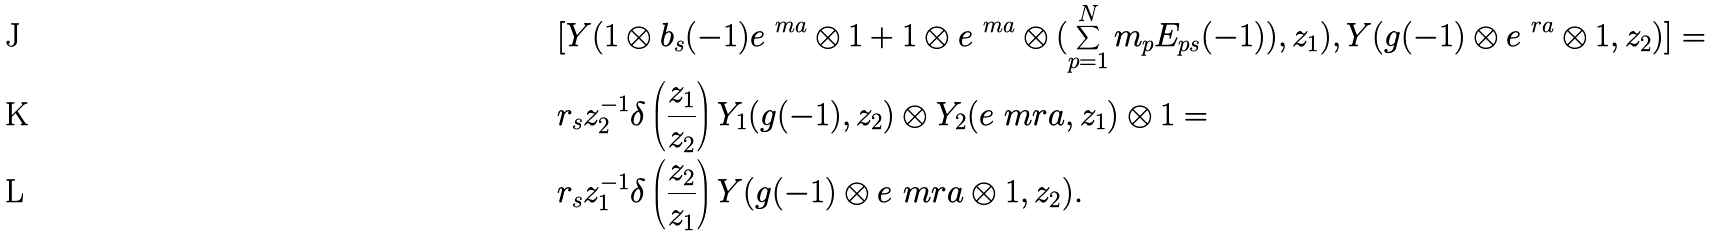<formula> <loc_0><loc_0><loc_500><loc_500>& [ Y ( 1 \otimes b _ { s } ( - 1 ) e ^ { \ m a } \otimes 1 + 1 \otimes e ^ { \ m a } \otimes ( \sum _ { p = 1 } ^ { N } m _ { p } E _ { p s } ( - 1 ) ) , z _ { 1 } ) , Y ( g ( - 1 ) \otimes e ^ { \ r a } \otimes 1 , z _ { 2 } ) ] = \\ & r _ { s } z _ { 2 } ^ { - 1 } \delta \left ( \frac { z _ { 1 } } { z _ { 2 } } \right ) Y _ { 1 } ( g ( - 1 ) , z _ { 2 } ) \otimes Y _ { 2 } ( e ^ { \ } m r a , z _ { 1 } ) \otimes 1 = \\ & r _ { s } z _ { 1 } ^ { - 1 } \delta \left ( \frac { z _ { 2 } } { z _ { 1 } } \right ) Y ( g ( - 1 ) \otimes e ^ { \ } m r a \otimes 1 , z _ { 2 } ) .</formula> 